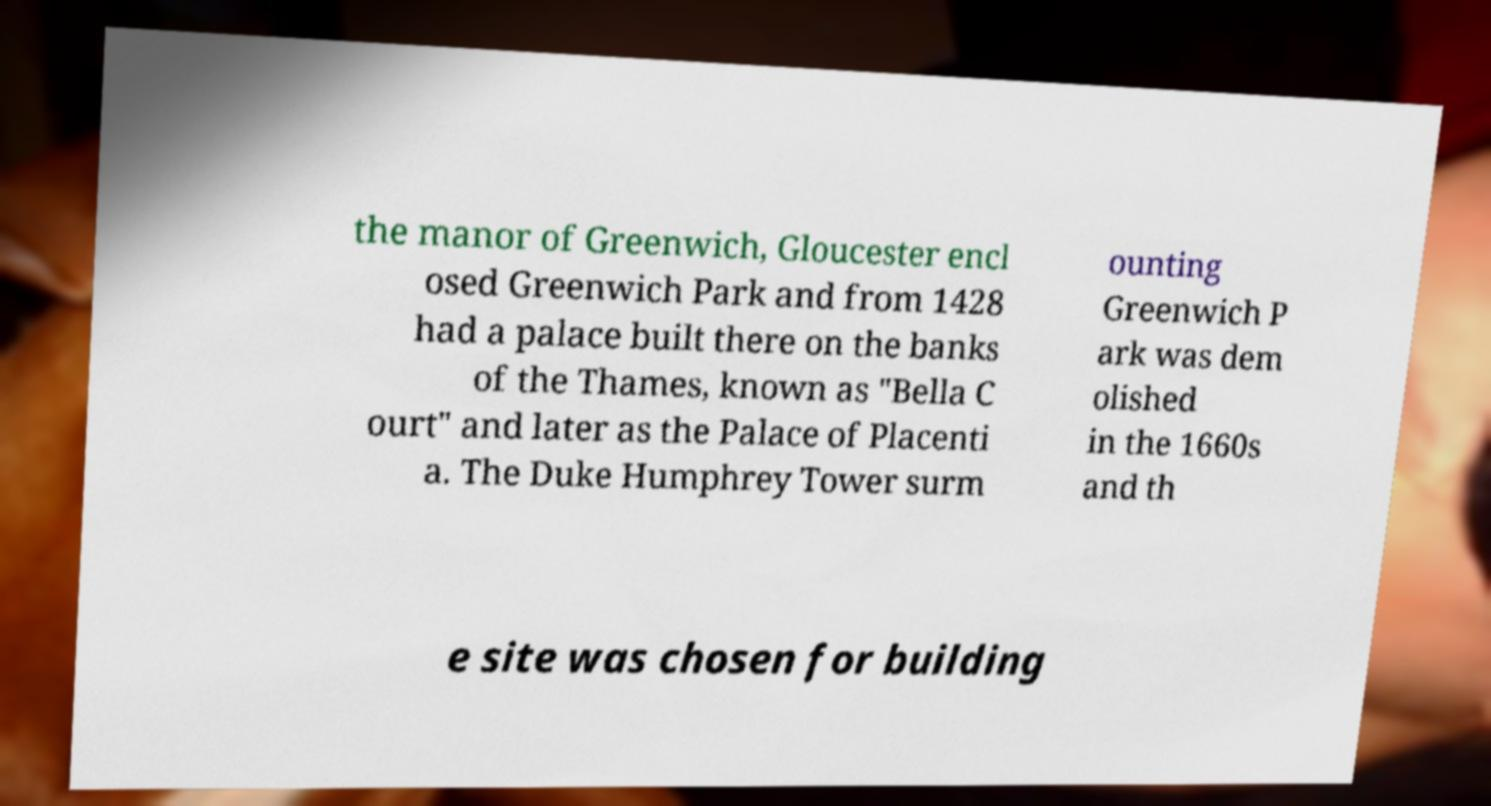Can you read and provide the text displayed in the image?This photo seems to have some interesting text. Can you extract and type it out for me? the manor of Greenwich, Gloucester encl osed Greenwich Park and from 1428 had a palace built there on the banks of the Thames, known as "Bella C ourt" and later as the Palace of Placenti a. The Duke Humphrey Tower surm ounting Greenwich P ark was dem olished in the 1660s and th e site was chosen for building 